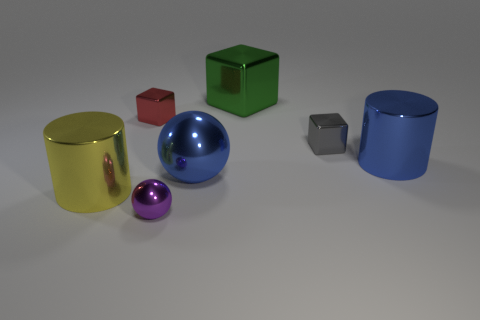Subtract all small cubes. How many cubes are left? 1 Add 1 big red matte cylinders. How many objects exist? 8 Subtract all cylinders. How many objects are left? 5 Subtract all tiny cyan rubber objects. Subtract all large yellow shiny cylinders. How many objects are left? 6 Add 6 blue cylinders. How many blue cylinders are left? 7 Add 6 gray objects. How many gray objects exist? 7 Subtract 1 purple spheres. How many objects are left? 6 